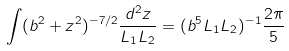Convert formula to latex. <formula><loc_0><loc_0><loc_500><loc_500>\int ( b ^ { 2 } + z ^ { 2 } ) ^ { - 7 / 2 } \frac { d ^ { 2 } z } { L _ { 1 } L _ { 2 } } = ( b ^ { 5 } L _ { 1 } L _ { 2 } ) ^ { - 1 } \frac { 2 \pi } { 5 }</formula> 